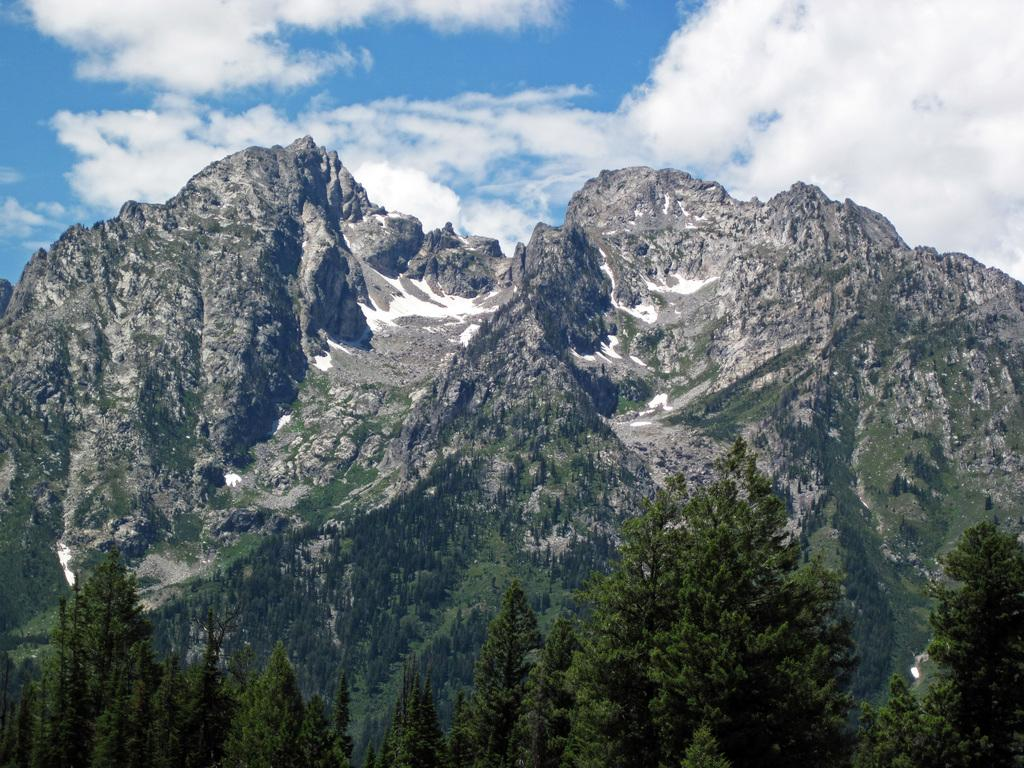What type of vegetation is at the bottom of the image? There are trees at the bottom of the image. What geographical features are in the middle of the image? There are hills in the middle of the image. What is visible at the top of the image? The sky is visible at the top of the image. What can be seen in the sky in the image? Clouds are present in the sky. Where is the throne located in the image? There is no throne present in the image. What type of meat is being grilled on the hills in the image? There is no meat or grilling activity present in the image; it features trees, hills, and clouds. 